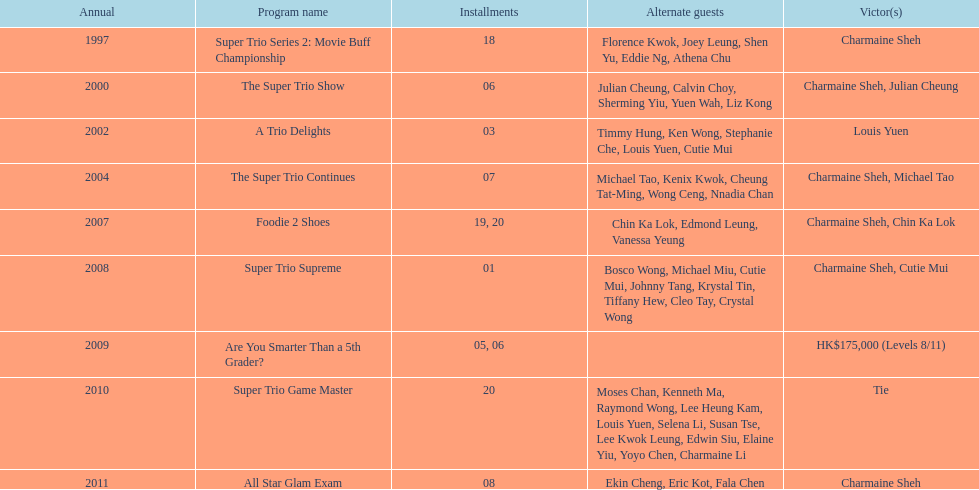How many of shows had at least 5 episodes? 7. 